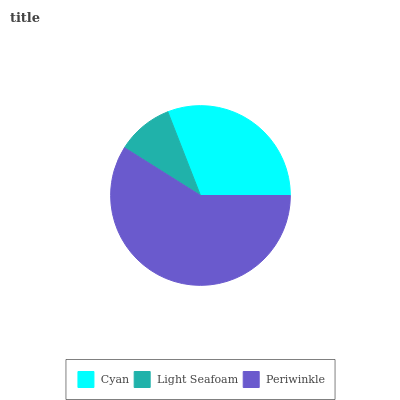Is Light Seafoam the minimum?
Answer yes or no. Yes. Is Periwinkle the maximum?
Answer yes or no. Yes. Is Periwinkle the minimum?
Answer yes or no. No. Is Light Seafoam the maximum?
Answer yes or no. No. Is Periwinkle greater than Light Seafoam?
Answer yes or no. Yes. Is Light Seafoam less than Periwinkle?
Answer yes or no. Yes. Is Light Seafoam greater than Periwinkle?
Answer yes or no. No. Is Periwinkle less than Light Seafoam?
Answer yes or no. No. Is Cyan the high median?
Answer yes or no. Yes. Is Cyan the low median?
Answer yes or no. Yes. Is Light Seafoam the high median?
Answer yes or no. No. Is Periwinkle the low median?
Answer yes or no. No. 